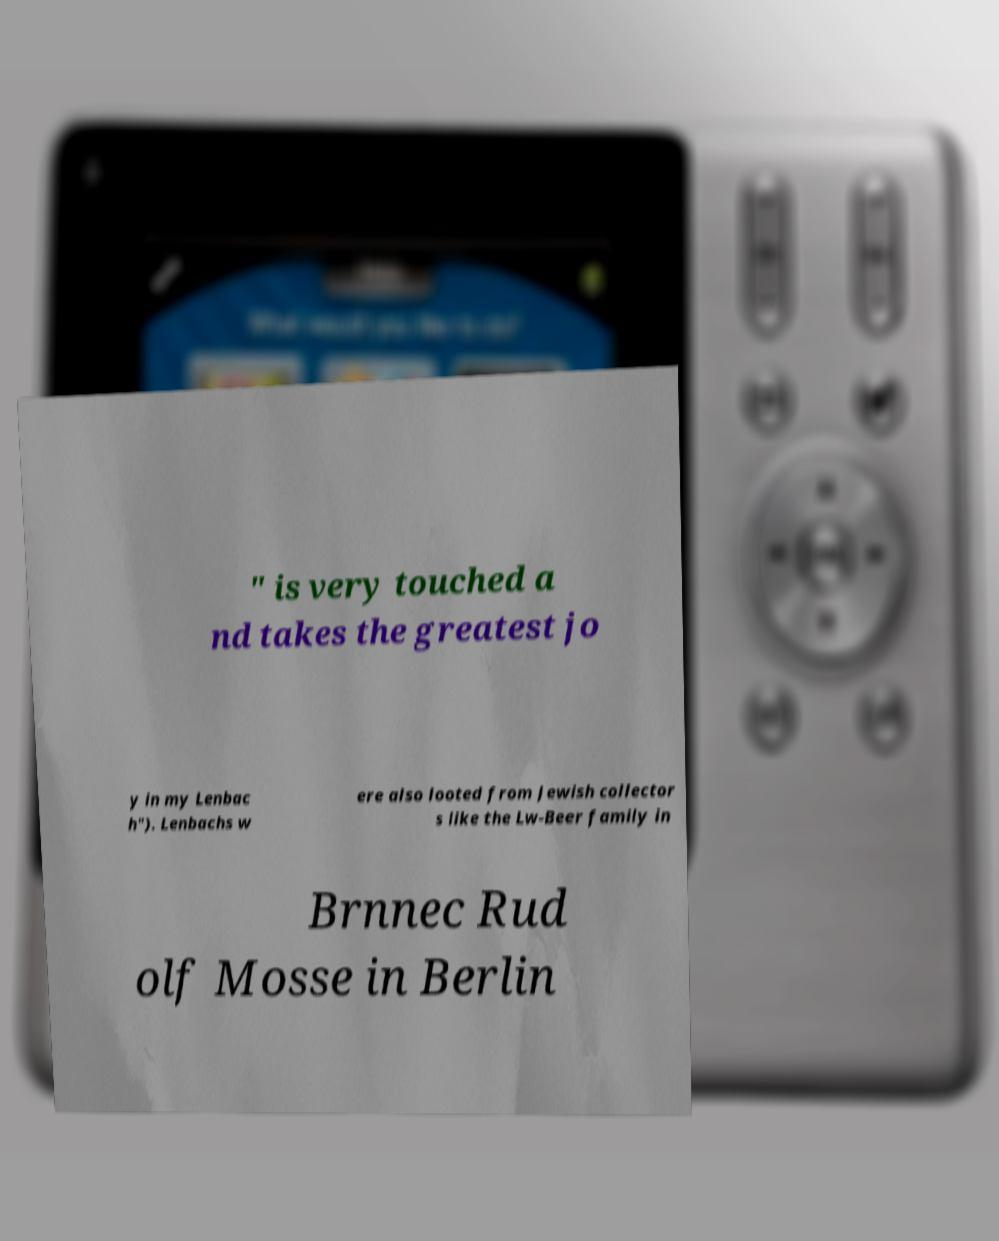Can you accurately transcribe the text from the provided image for me? " is very touched a nd takes the greatest jo y in my Lenbac h"). Lenbachs w ere also looted from Jewish collector s like the Lw-Beer family in Brnnec Rud olf Mosse in Berlin 